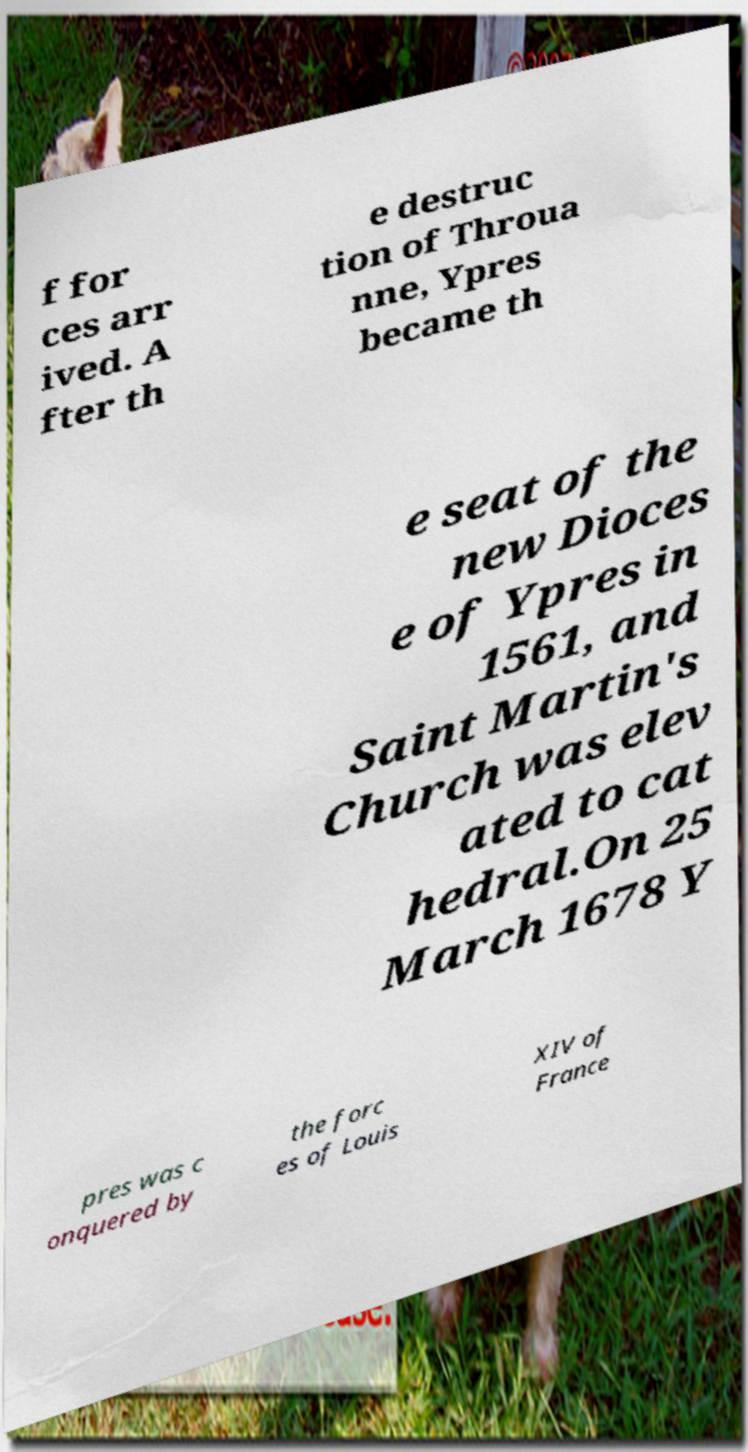Can you read and provide the text displayed in the image?This photo seems to have some interesting text. Can you extract and type it out for me? f for ces arr ived. A fter th e destruc tion of Throua nne, Ypres became th e seat of the new Dioces e of Ypres in 1561, and Saint Martin's Church was elev ated to cat hedral.On 25 March 1678 Y pres was c onquered by the forc es of Louis XIV of France 